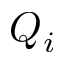<formula> <loc_0><loc_0><loc_500><loc_500>Q _ { i }</formula> 